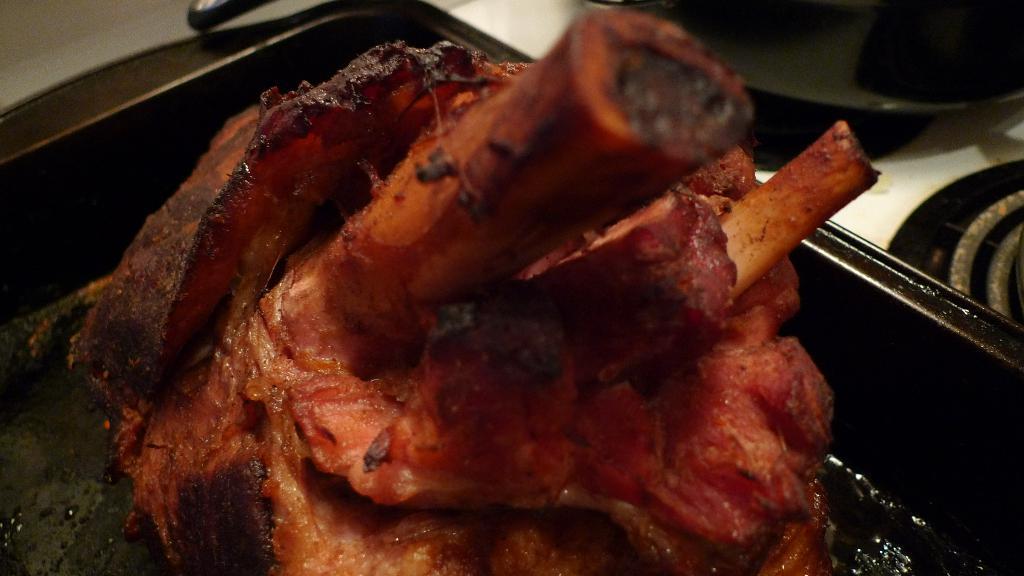In one or two sentences, can you explain what this image depicts? In this image in the foreground there is some meat in a tray, and in the background there are some pans and a stove. 